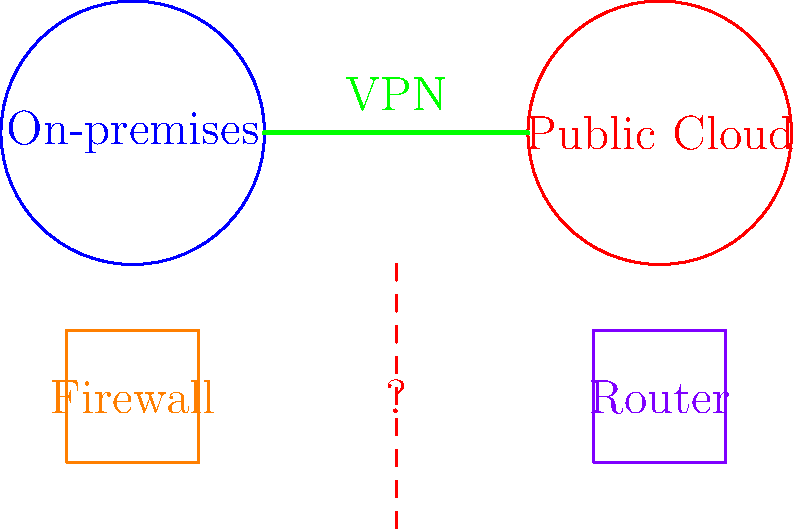In a hybrid cloud network setup, connectivity issues are reported between the on-premises network and the public cloud environment. The VPN connection appears to be established, but data transfer is inconsistent. What should be the first step in troubleshooting this issue? To troubleshoot this connectivity issue in a hybrid cloud network, follow these steps:

1. Verify VPN status: Although the VPN appears to be established, confirm its status and stability.

2. Check firewall rules: Examine the firewall configurations on both the on-premises and cloud sides to ensure proper traffic flow.

3. Analyze network routes: Verify that the correct routes are configured on both the on-premises router and the cloud router.

4. Test basic connectivity: Use ping and traceroute to check basic connectivity and identify where packets might be dropped.

5. Examine network logs: Look for any error messages or unusual patterns in the network logs of both environments.

6. Verify security groups and ACLs: Check if any security groups or Access Control Lists in the cloud environment are blocking traffic.

7. Monitor bandwidth and latency: Use network monitoring tools to check for any bandwidth limitations or high latency issues.

8. Check for MTU mismatches: Verify that the Maximum Transmission Unit (MTU) settings are consistent across the network.

Given that the VPN connection appears to be established but data transfer is inconsistent, the most logical first step would be to check the firewall rules. Firewalls can often cause intermittent connectivity issues if not configured correctly, especially in a hybrid cloud setup where different security policies might be in place.
Answer: Check firewall rules 